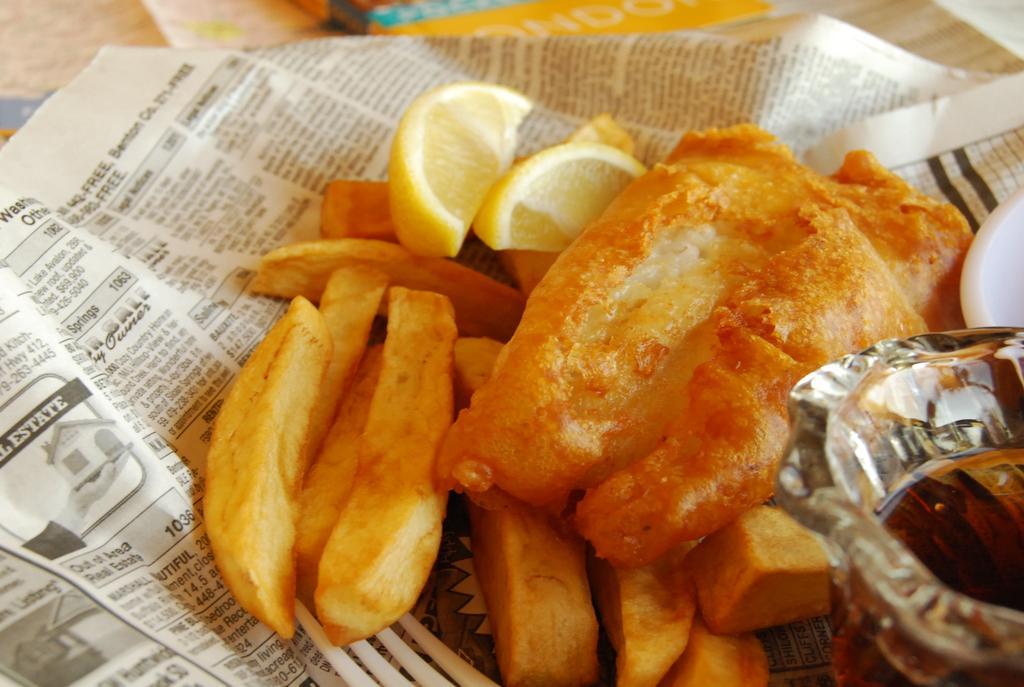<image>
Share a concise interpretation of the image provided. fries and lemons on top of a newspaper page that is open and says 'real estate' on it 